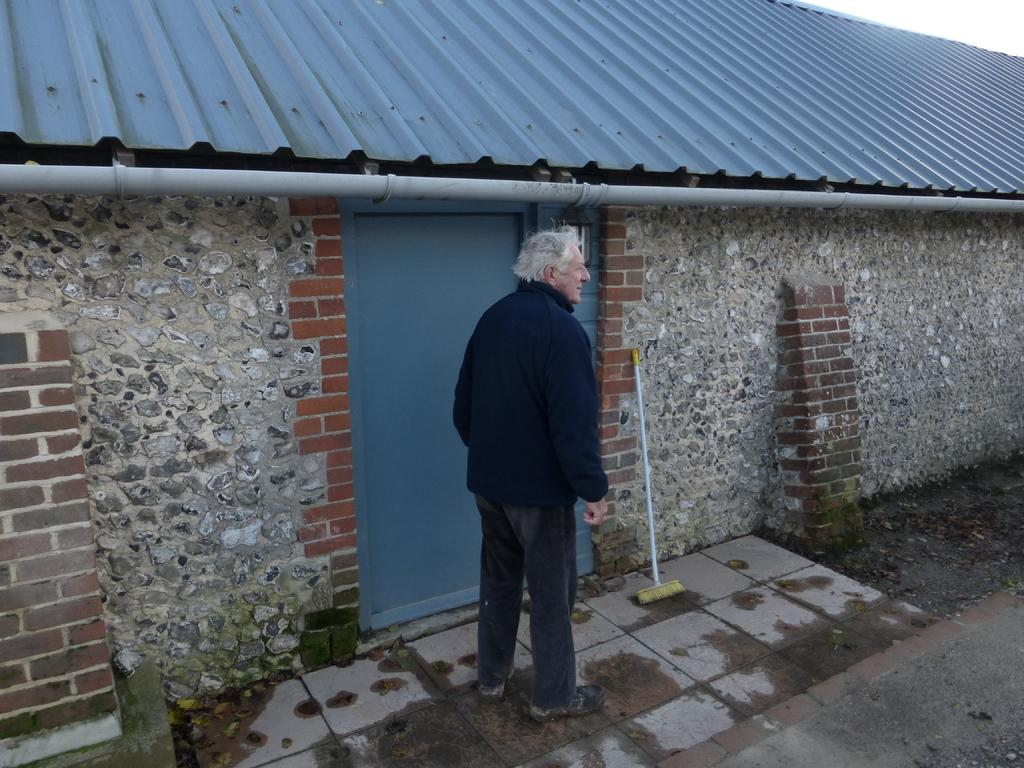What is the main subject of the image? There is a person standing in the image. What direction is the person looking in? The person is looking to the right side of the image. What can be seen in front of the person? There is a door of a house in front of the person. What object is located beside the door? There is an object beside the door. How many rings are visible on the person's fingers in the image? There is no information about rings on the person's fingers in the provided facts, so we cannot determine the number of rings visible. 